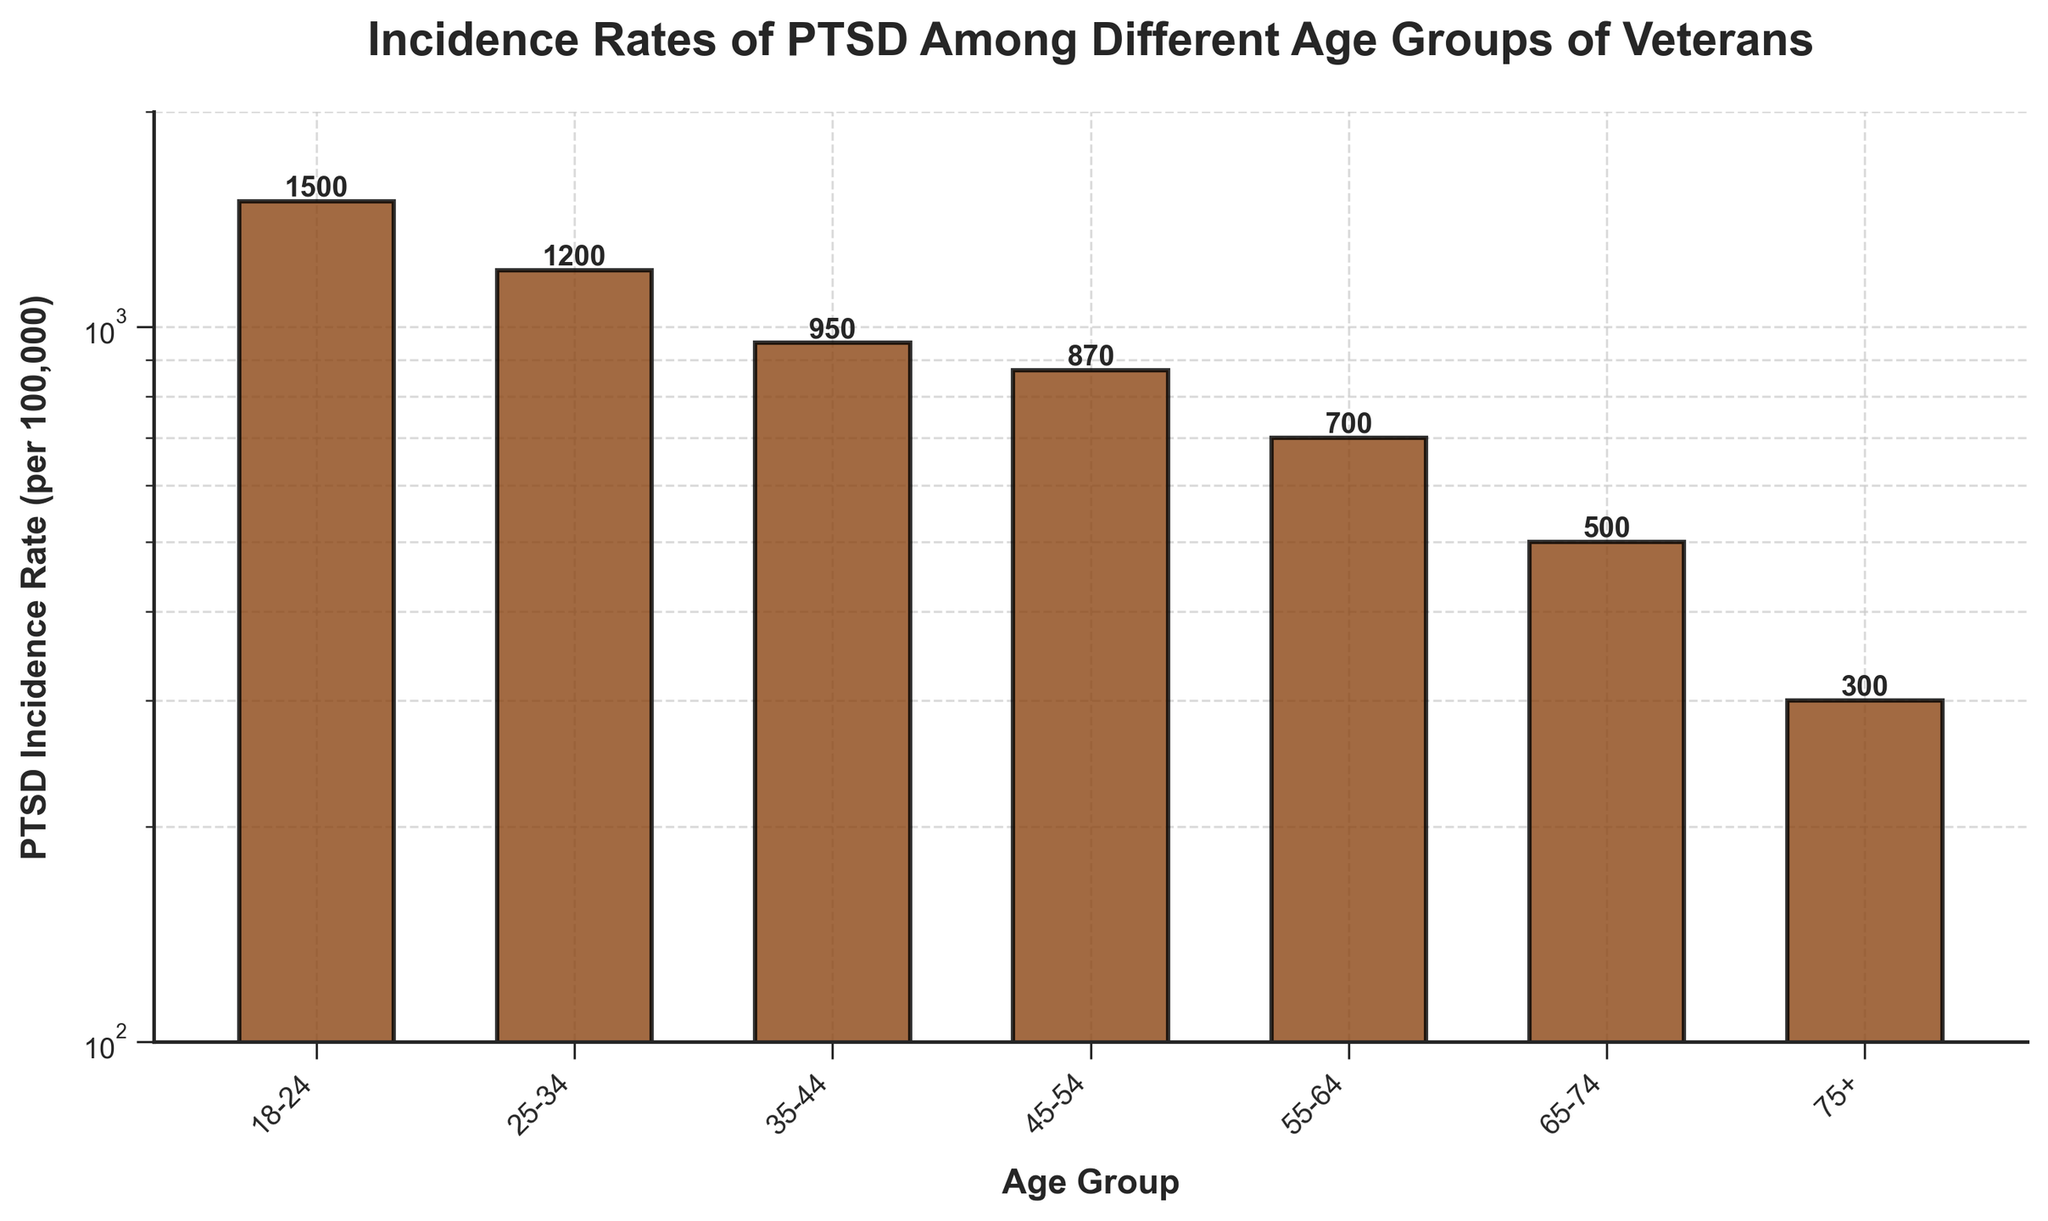What's the title of the figure? The title is located at the top of the figure and provides a summary of what the figure displays. Here, the title specifically describes that the plot shows the incidence rates of PTSD among different age groups of veterans.
Answer: Incidence Rates of PTSD Among Different Age Groups of Veterans Which age group has the highest incidence rate of PTSD? By observing the height of the bars in the plot, the highest bar corresponds to the age group '18-24'.
Answer: 18-24 What is the PTSD incidence rate for the 45-54 age group? Look for the bar labeled '45-54', and check the value annotated above or the height of the bar. The annotation says 870 per 100,000.
Answer: 870 per 100,000 How does the incidence rate for the 75+ age group compare to the 55-64 age group? Compare the heights of the bars for the '75+' and '55-64' age groups or their annotated values. The '75+' label shows 300, which is lower than the '55-64' value of 700.
Answer: Lower What is the difference in incidence rate between the age groups 18-24 and 55-64? Subtract the incidence rate of the 55-64 age group from that of the 18-24 age group. So, 1500 per 100,000 minus 700 per 100,000 equals 800 per 100,000.
Answer: 800 per 100,000 What's the average PTSD incidence rate across all age groups? Add the incidence rates of all age groups and divide by the total number of age groups: (1500 + 1200 + 950 + 870 + 700 + 500 + 300) / 7. This equals 6020 / 7, which is approximately 860 per 100,000.
Answer: 860 per 100,000 Which age group has less than half the incidence rate of PTSD compared to the 25-34 age group? The incidence rate of the 25-34 age group is 1200 per 100,000. Half of this is 600 per 100,000. The only age groups with rates less than 600 are '65-74' (500 per 100,000) and '75+' (300 per 100,000).
Answer: 65-74 and 75+ Why might the plot use a log scale instead of a linear scale for the y-axis? A log scale is often used when there is a wide range of data values to compress the large range and make patterns more visible. Here, the incidence rates range from 300 to 1500, and a log scale helps to better visualize the differences between smaller values.
Answer: To better visualize differences over a wide range of values For which age group is the incidence rate closest to 1000 per 100,000? Find the age group with an incidence rate nearest to 1000 per 100,000 by looking at the annotations. The '35-44' age group has an incidence rate of 950, which is closest to 1000.
Answer: 35-44 